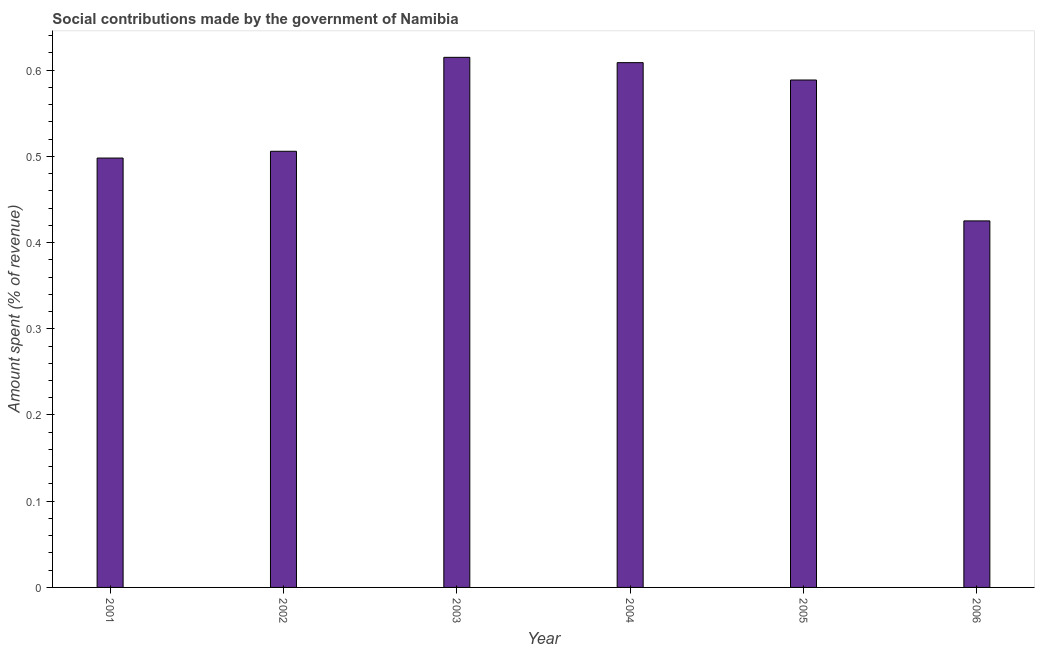Does the graph contain any zero values?
Your answer should be very brief. No. Does the graph contain grids?
Provide a succinct answer. No. What is the title of the graph?
Make the answer very short. Social contributions made by the government of Namibia. What is the label or title of the X-axis?
Ensure brevity in your answer.  Year. What is the label or title of the Y-axis?
Keep it short and to the point. Amount spent (% of revenue). What is the amount spent in making social contributions in 2005?
Offer a terse response. 0.59. Across all years, what is the maximum amount spent in making social contributions?
Offer a terse response. 0.61. Across all years, what is the minimum amount spent in making social contributions?
Offer a very short reply. 0.43. In which year was the amount spent in making social contributions maximum?
Keep it short and to the point. 2003. In which year was the amount spent in making social contributions minimum?
Your answer should be very brief. 2006. What is the sum of the amount spent in making social contributions?
Give a very brief answer. 3.24. What is the difference between the amount spent in making social contributions in 2001 and 2005?
Ensure brevity in your answer.  -0.09. What is the average amount spent in making social contributions per year?
Your answer should be compact. 0.54. What is the median amount spent in making social contributions?
Make the answer very short. 0.55. In how many years, is the amount spent in making social contributions greater than 0.26 %?
Your answer should be very brief. 6. Do a majority of the years between 2003 and 2004 (inclusive) have amount spent in making social contributions greater than 0.02 %?
Make the answer very short. Yes. What is the ratio of the amount spent in making social contributions in 2001 to that in 2004?
Provide a short and direct response. 0.82. What is the difference between the highest and the second highest amount spent in making social contributions?
Provide a short and direct response. 0.01. Is the sum of the amount spent in making social contributions in 2004 and 2006 greater than the maximum amount spent in making social contributions across all years?
Give a very brief answer. Yes. What is the difference between the highest and the lowest amount spent in making social contributions?
Keep it short and to the point. 0.19. Are all the bars in the graph horizontal?
Provide a succinct answer. No. How many years are there in the graph?
Provide a short and direct response. 6. What is the Amount spent (% of revenue) of 2001?
Make the answer very short. 0.5. What is the Amount spent (% of revenue) in 2002?
Provide a succinct answer. 0.51. What is the Amount spent (% of revenue) of 2003?
Make the answer very short. 0.61. What is the Amount spent (% of revenue) of 2004?
Your response must be concise. 0.61. What is the Amount spent (% of revenue) in 2005?
Your answer should be very brief. 0.59. What is the Amount spent (% of revenue) of 2006?
Your answer should be very brief. 0.43. What is the difference between the Amount spent (% of revenue) in 2001 and 2002?
Ensure brevity in your answer.  -0.01. What is the difference between the Amount spent (% of revenue) in 2001 and 2003?
Give a very brief answer. -0.12. What is the difference between the Amount spent (% of revenue) in 2001 and 2004?
Your response must be concise. -0.11. What is the difference between the Amount spent (% of revenue) in 2001 and 2005?
Give a very brief answer. -0.09. What is the difference between the Amount spent (% of revenue) in 2001 and 2006?
Provide a succinct answer. 0.07. What is the difference between the Amount spent (% of revenue) in 2002 and 2003?
Your response must be concise. -0.11. What is the difference between the Amount spent (% of revenue) in 2002 and 2004?
Give a very brief answer. -0.1. What is the difference between the Amount spent (% of revenue) in 2002 and 2005?
Your answer should be very brief. -0.08. What is the difference between the Amount spent (% of revenue) in 2002 and 2006?
Your answer should be very brief. 0.08. What is the difference between the Amount spent (% of revenue) in 2003 and 2004?
Make the answer very short. 0.01. What is the difference between the Amount spent (% of revenue) in 2003 and 2005?
Your response must be concise. 0.03. What is the difference between the Amount spent (% of revenue) in 2003 and 2006?
Give a very brief answer. 0.19. What is the difference between the Amount spent (% of revenue) in 2004 and 2005?
Offer a very short reply. 0.02. What is the difference between the Amount spent (% of revenue) in 2004 and 2006?
Offer a very short reply. 0.18. What is the difference between the Amount spent (% of revenue) in 2005 and 2006?
Provide a succinct answer. 0.16. What is the ratio of the Amount spent (% of revenue) in 2001 to that in 2002?
Give a very brief answer. 0.98. What is the ratio of the Amount spent (% of revenue) in 2001 to that in 2003?
Keep it short and to the point. 0.81. What is the ratio of the Amount spent (% of revenue) in 2001 to that in 2004?
Offer a very short reply. 0.82. What is the ratio of the Amount spent (% of revenue) in 2001 to that in 2005?
Give a very brief answer. 0.85. What is the ratio of the Amount spent (% of revenue) in 2001 to that in 2006?
Ensure brevity in your answer.  1.17. What is the ratio of the Amount spent (% of revenue) in 2002 to that in 2003?
Your response must be concise. 0.82. What is the ratio of the Amount spent (% of revenue) in 2002 to that in 2004?
Your answer should be compact. 0.83. What is the ratio of the Amount spent (% of revenue) in 2002 to that in 2005?
Keep it short and to the point. 0.86. What is the ratio of the Amount spent (% of revenue) in 2002 to that in 2006?
Your answer should be compact. 1.19. What is the ratio of the Amount spent (% of revenue) in 2003 to that in 2005?
Offer a terse response. 1.04. What is the ratio of the Amount spent (% of revenue) in 2003 to that in 2006?
Give a very brief answer. 1.45. What is the ratio of the Amount spent (% of revenue) in 2004 to that in 2005?
Your answer should be compact. 1.03. What is the ratio of the Amount spent (% of revenue) in 2004 to that in 2006?
Provide a short and direct response. 1.43. What is the ratio of the Amount spent (% of revenue) in 2005 to that in 2006?
Offer a terse response. 1.38. 